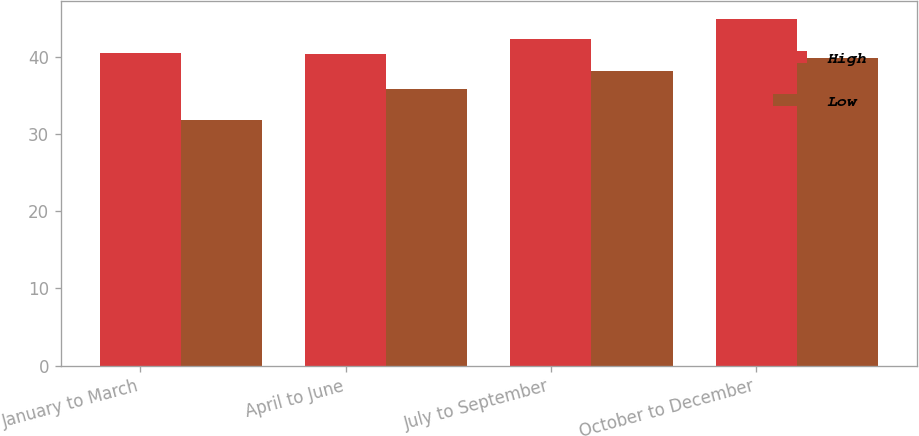Convert chart to OTSL. <chart><loc_0><loc_0><loc_500><loc_500><stacked_bar_chart><ecel><fcel>January to March<fcel>April to June<fcel>July to September<fcel>October to December<nl><fcel>High<fcel>40.46<fcel>40.33<fcel>42.27<fcel>44.96<nl><fcel>Low<fcel>31.8<fcel>35.84<fcel>38.17<fcel>39.87<nl></chart> 